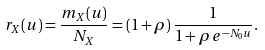Convert formula to latex. <formula><loc_0><loc_0><loc_500><loc_500>r _ { X } ( u ) = \frac { m _ { X } ( u ) } { N _ { X } } = ( 1 + \rho ) \, \frac { 1 } { 1 + \rho \, e ^ { - N _ { 0 } u } } .</formula> 